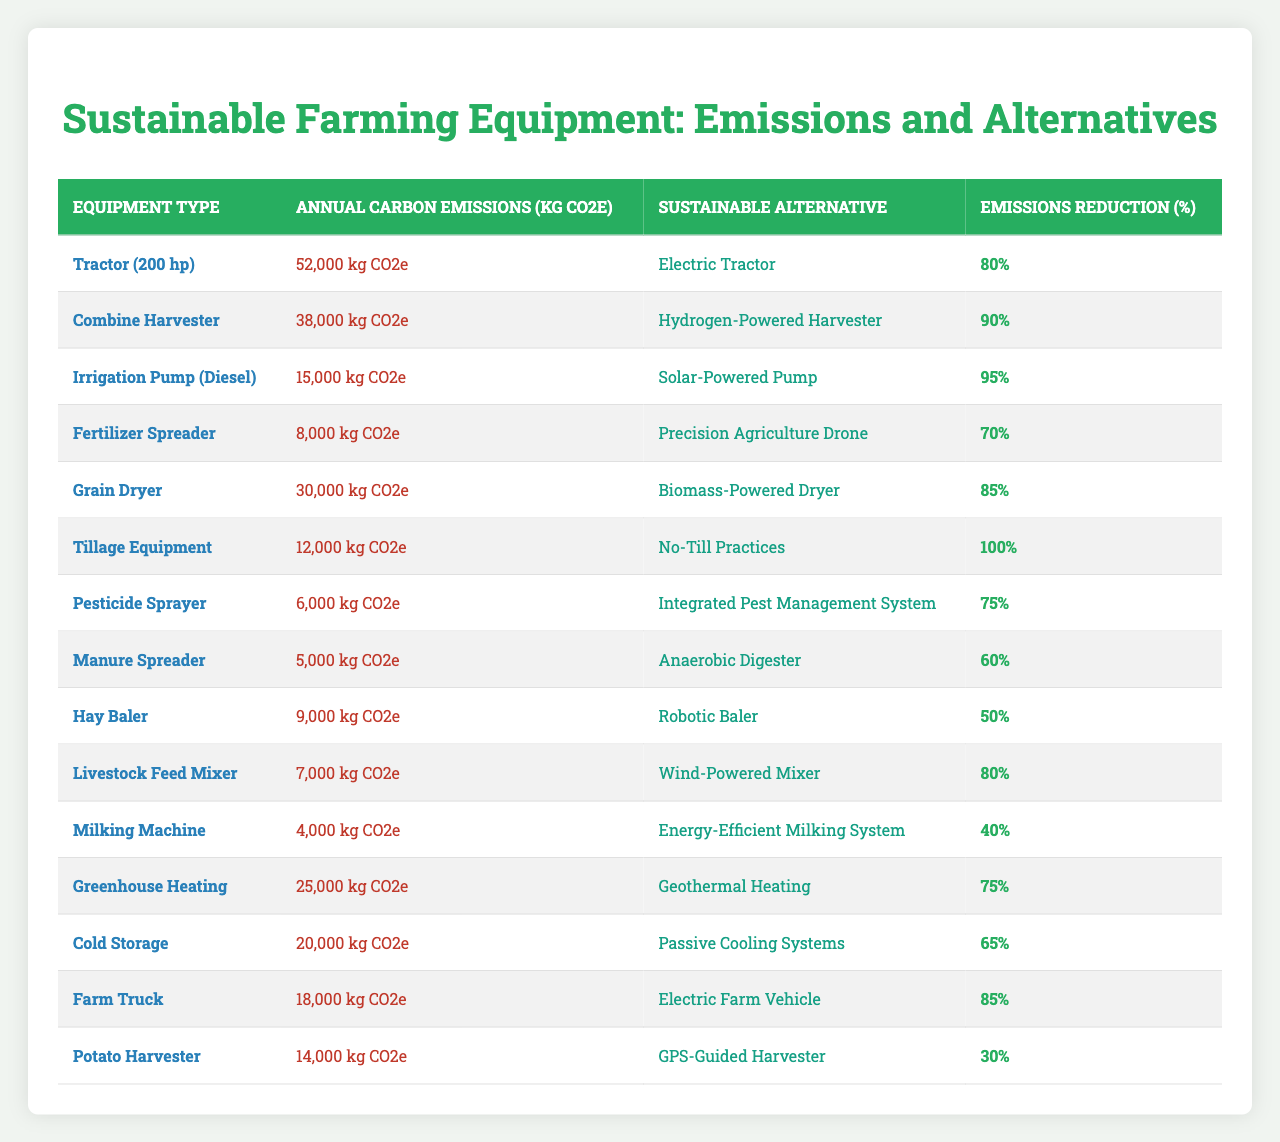What is the annual carbon emission for a Combine Harvester? The table lists the annual carbon emissions for each type of equipment. For the Combine Harvester, the emissions are specifically stated as 38,000 kg CO2e.
Answer: 38,000 kg CO2e Which sustainable alternative has the highest emissions reduction percentage? The table shows the emissions reduction percentages for each alternative. The Hydrogen-Powered Harvester associated with the Combine Harvester has the highest reduction at 90%.
Answer: Hydrogen-Powered Harvester (90%) What is the total annual carbon emissions for Tillage Equipment and Fertilizer Spreader combined? From the table, Tillage Equipment has emissions of 12,000 kg CO2e, and the Fertilizer Spreader has emissions of 8,000 kg CO2e. Adding both gives: 12,000 + 8,000 = 20,000 kg CO2e.
Answer: 20,000 kg CO2e Is the annual carbon emission for a Livestock Feed Mixer less than that for a Manure Spreader? The annual carbon emissions for the Livestock Feed Mixer are 7,000 kg CO2e and for the Manure Spreader are 5,000 kg CO2e. Since 7,000 is greater than 5,000, the statement is false.
Answer: No What is the average emissions reduction percentage for all equipment types listed? To find the average, add all the emissions reduction percentages: 80 + 90 + 95 + 70 + 85 + 100 + 75 + 60 + 50 + 80 + 40 + 75 + 65 + 85 + 30 = 1,165. There are 15 entries, so the average is 1,165 / 15 = 77.67%.
Answer: 77.67% Which equipment type has the lowest annual carbon emissions? The table indicates that the Milking Machine has the lowest annual carbon emission at 4,000 kg CO2e compared to all other listed equipment types.
Answer: Milking Machine (4,000 kg CO2e) What is the emissions reduction percentage if a Grain Dryer is replaced with a Biomass-Powered Dryer? The table specifies that switching from a Grain Dryer (30,000 kg CO2e) to a Biomass-Powered Dryer results in an emissions reduction of 85%.
Answer: 85% If both the Electric Farm Vehicle and Solar-Powered Pump are used, what is the total emissions reduction? The Electric Farm Vehicle has an emissions reduction of 85%, and the Solar-Powered Pump has an emissions reduction of 95%. To find the total emissions reduction when used together would take an analysis of emissions separately rather than cumulatively. Thus, the combined total cannot be simply summed, as they don't operate together but are independent.
Answer: Not applicable Which equipment has an emissions reduction percentage less than 50%? According to the table, the Hay Baler has an emissions reduction percentage of 50%, and the Milking Machine has a reduction of 40%. Therefore, the Milking Machine is the only equipment with less than a 50% reduction.
Answer: Milking Machine (40%) 